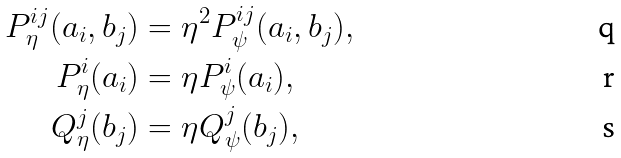<formula> <loc_0><loc_0><loc_500><loc_500>P ^ { i j } _ { \eta } ( a _ { i } , b _ { j } ) & = \eta ^ { 2 } P ^ { i j } _ { \psi } ( a _ { i } , b _ { j } ) , \\ P ^ { i } _ { \eta } ( a _ { i } ) & = \eta P ^ { i } _ { \psi } ( a _ { i } ) , \\ Q ^ { j } _ { \eta } ( b _ { j } ) & = \eta Q ^ { j } _ { \psi } ( b _ { j } ) ,</formula> 